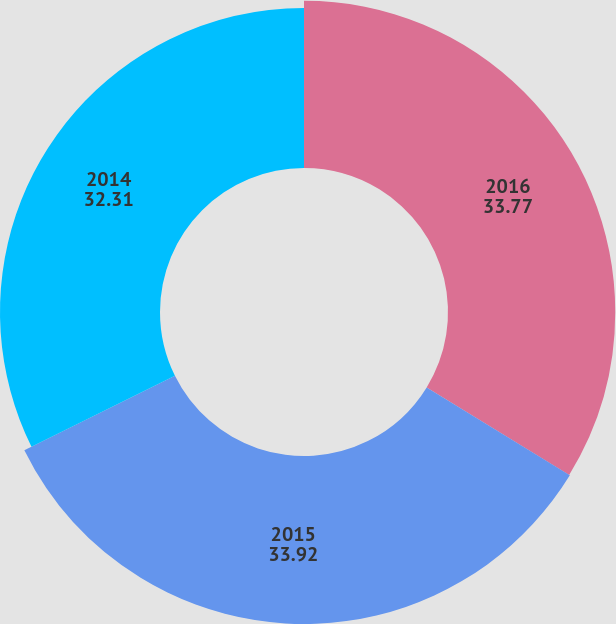Convert chart to OTSL. <chart><loc_0><loc_0><loc_500><loc_500><pie_chart><fcel>2016<fcel>2015<fcel>2014<nl><fcel>33.77%<fcel>33.92%<fcel>32.31%<nl></chart> 